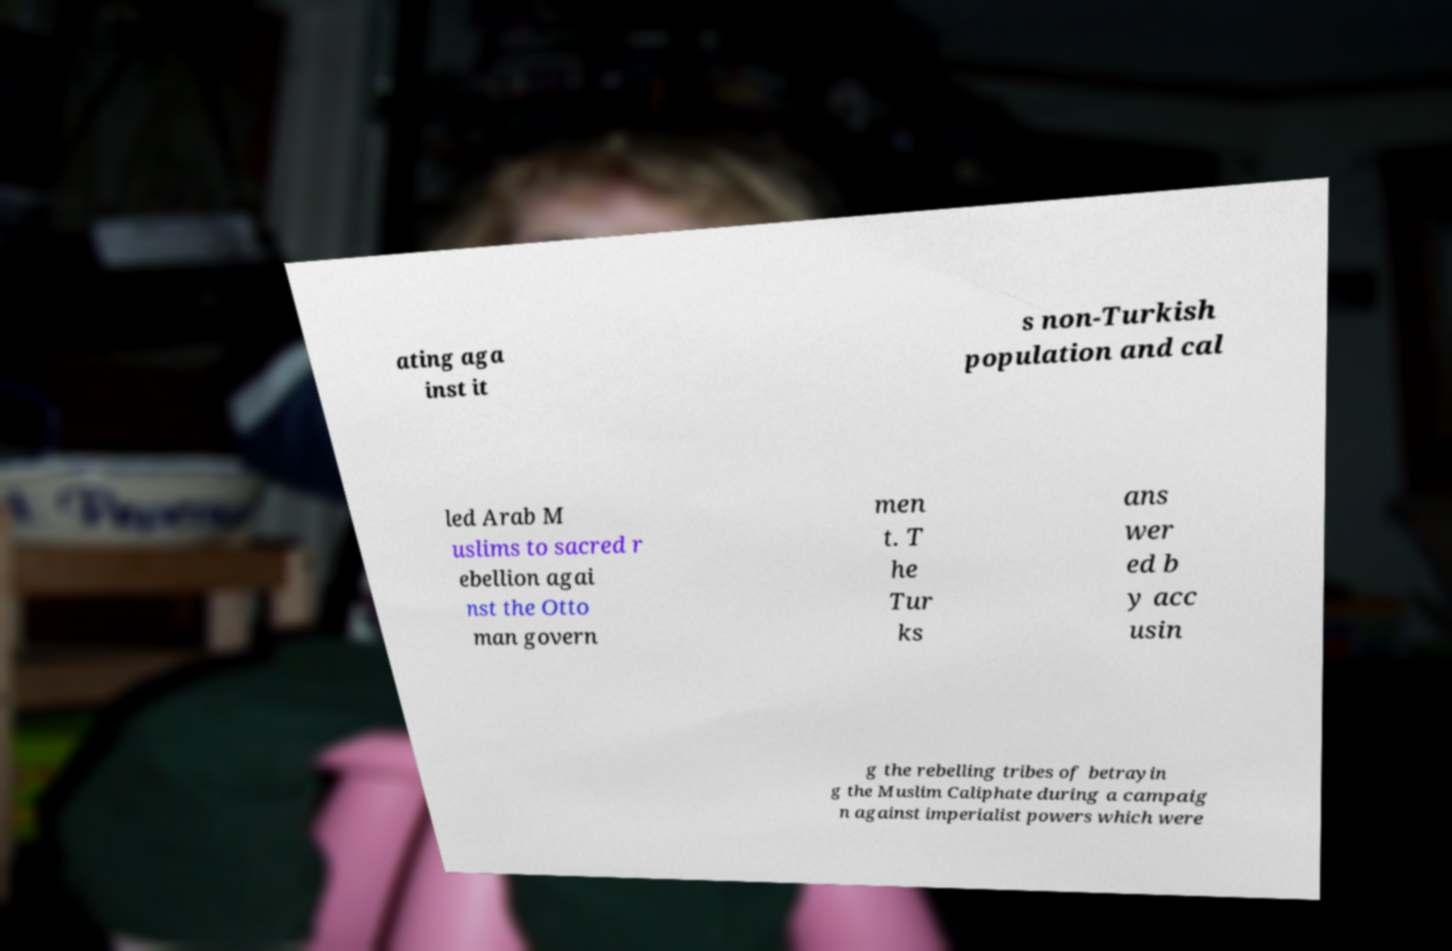Please identify and transcribe the text found in this image. ating aga inst it s non-Turkish population and cal led Arab M uslims to sacred r ebellion agai nst the Otto man govern men t. T he Tur ks ans wer ed b y acc usin g the rebelling tribes of betrayin g the Muslim Caliphate during a campaig n against imperialist powers which were 